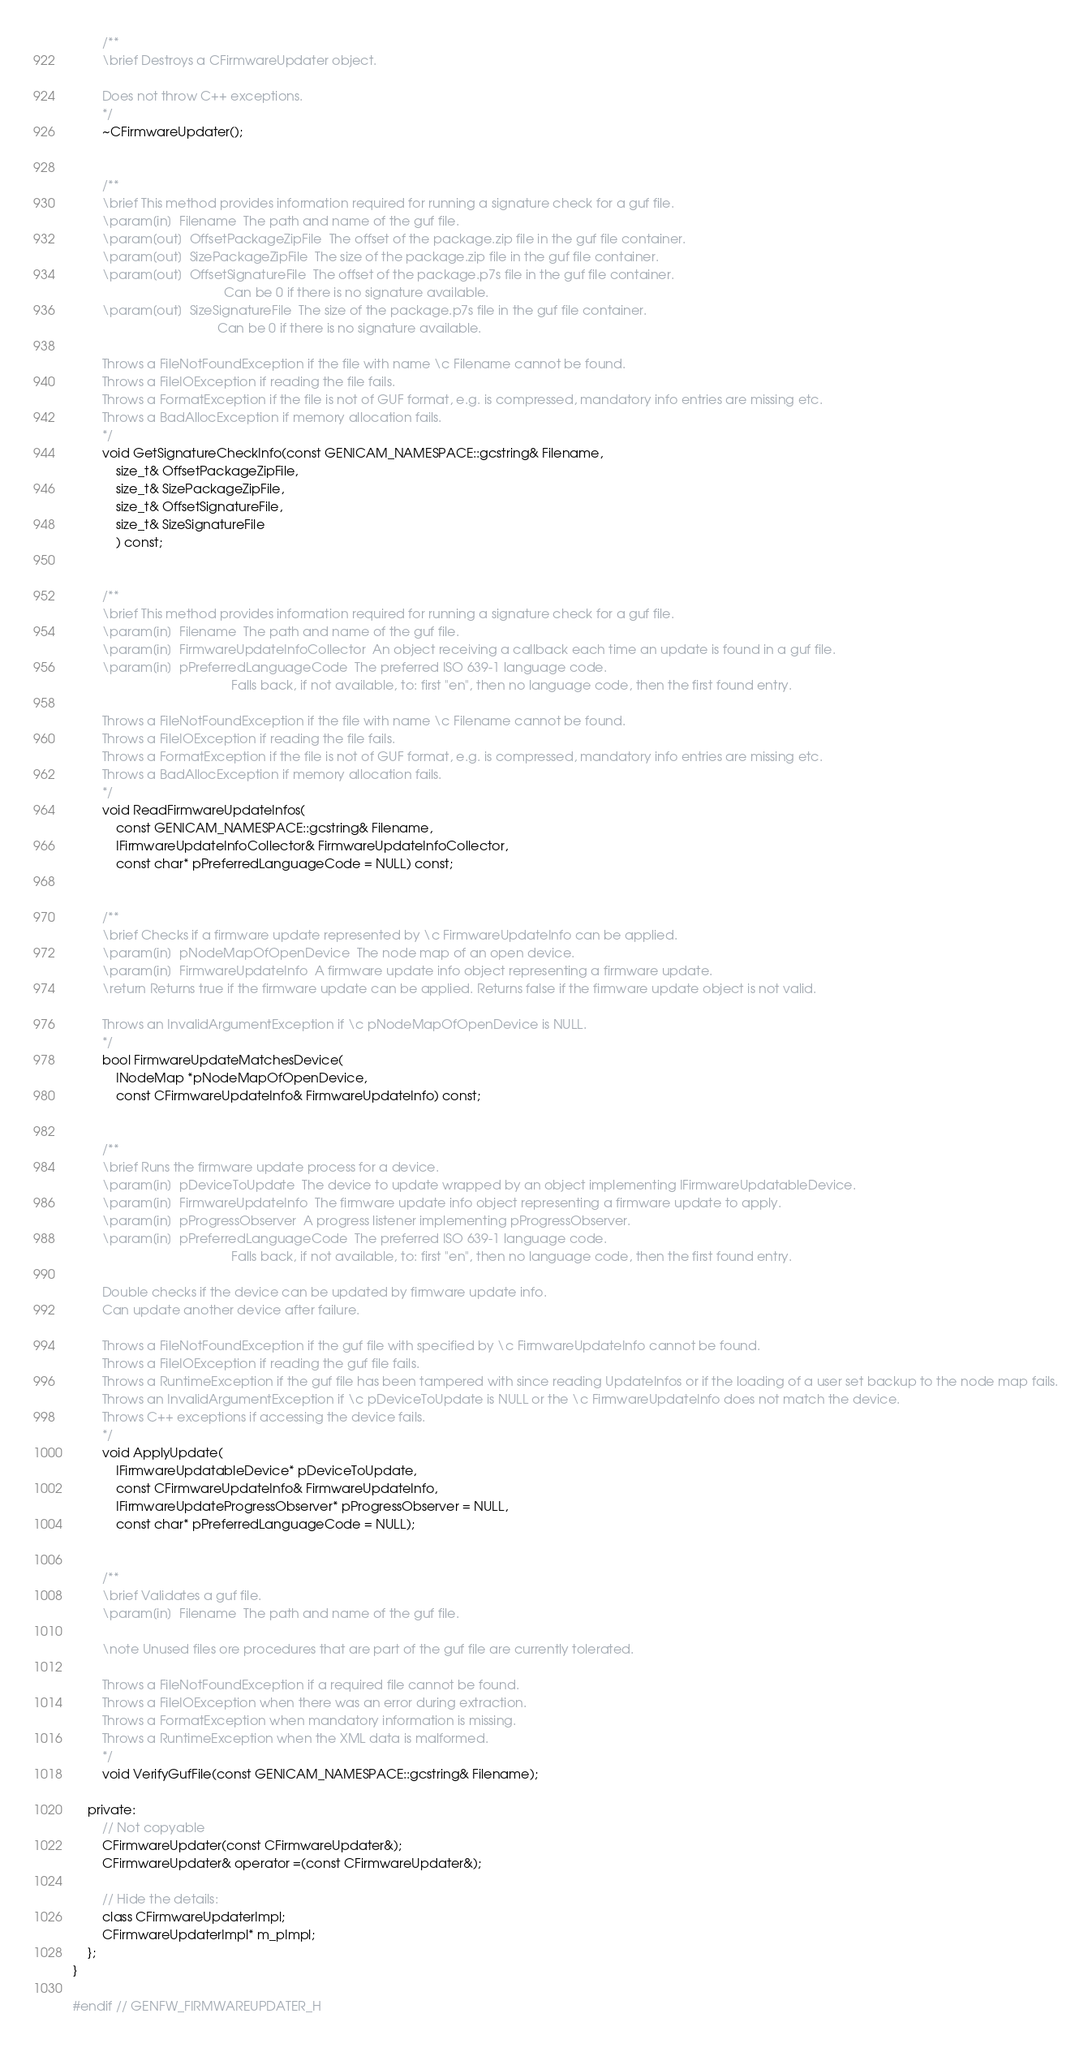<code> <loc_0><loc_0><loc_500><loc_500><_C_>
        /**
        \brief Destroys a CFirmwareUpdater object.

        Does not throw C++ exceptions.
        */
        ~CFirmwareUpdater();


        /**
        \brief This method provides information required for running a signature check for a guf file.
        \param[in]  Filename  The path and name of the guf file.
        \param[out]  OffsetPackageZipFile  The offset of the package.zip file in the guf file container.
        \param[out]  SizePackageZipFile  The size of the package.zip file in the guf file container.
        \param[out]  OffsetSignatureFile  The offset of the package.p7s file in the guf file container.
                                          Can be 0 if there is no signature available.
        \param[out]  SizeSignatureFile  The size of the package.p7s file in the guf file container.
                                        Can be 0 if there is no signature available.

        Throws a FileNotFoundException if the file with name \c Filename cannot be found.
        Throws a FileIOException if reading the file fails.
        Throws a FormatException if the file is not of GUF format, e.g. is compressed, mandatory info entries are missing etc. 
        Throws a BadAllocException if memory allocation fails.
        */
        void GetSignatureCheckInfo(const GENICAM_NAMESPACE::gcstring& Filename,
            size_t& OffsetPackageZipFile,
            size_t& SizePackageZipFile,
            size_t& OffsetSignatureFile,
            size_t& SizeSignatureFile
            ) const;


        /**
        \brief This method provides information required for running a signature check for a guf file.
        \param[in]  Filename  The path and name of the guf file.
        \param[in]  FirmwareUpdateInfoCollector  An object receiving a callback each time an update is found in a guf file.
        \param[in]  pPreferredLanguageCode  The preferred ISO 639-1 language code. 
                                            Falls back, if not available, to: first "en", then no language code, then the first found entry.

        Throws a FileNotFoundException if the file with name \c Filename cannot be found.
        Throws a FileIOException if reading the file fails.
        Throws a FormatException if the file is not of GUF format, e.g. is compressed, mandatory info entries are missing etc.
        Throws a BadAllocException if memory allocation fails.
        */
        void ReadFirmwareUpdateInfos(
            const GENICAM_NAMESPACE::gcstring& Filename,
            IFirmwareUpdateInfoCollector& FirmwareUpdateInfoCollector,
            const char* pPreferredLanguageCode = NULL) const;


        /**
        \brief Checks if a firmware update represented by \c FirmwareUpdateInfo can be applied.
        \param[in]  pNodeMapOfOpenDevice  The node map of an open device.
        \param[in]  FirmwareUpdateInfo  A firmware update info object representing a firmware update.
        \return Returns true if the firmware update can be applied. Returns false if the firmware update object is not valid.

        Throws an InvalidArgumentException if \c pNodeMapOfOpenDevice is NULL.
        */
        bool FirmwareUpdateMatchesDevice(
            INodeMap *pNodeMapOfOpenDevice,
            const CFirmwareUpdateInfo& FirmwareUpdateInfo) const;


        /**
        \brief Runs the firmware update process for a device.
        \param[in]  pDeviceToUpdate  The device to update wrapped by an object implementing IFirmwareUpdatableDevice.
        \param[in]  FirmwareUpdateInfo  The firmware update info object representing a firmware update to apply.
        \param[in]  pProgressObserver  A progress listener implementing pProgressObserver.
        \param[in]  pPreferredLanguageCode  The preferred ISO 639-1 language code.
                                            Falls back, if not available, to: first "en", then no language code, then the first found entry.

        Double checks if the device can be updated by firmware update info.
        Can update another device after failure.

        Throws a FileNotFoundException if the guf file with specified by \c FirmwareUpdateInfo cannot be found.
        Throws a FileIOException if reading the guf file fails.
        Throws a RuntimeException if the guf file has been tampered with since reading UpdateInfos or if the loading of a user set backup to the node map fails.
        Throws an InvalidArgumentException if \c pDeviceToUpdate is NULL or the \c FirmwareUpdateInfo does not match the device.
        Throws C++ exceptions if accessing the device fails.
        */
        void ApplyUpdate(
            IFirmwareUpdatableDevice* pDeviceToUpdate,
            const CFirmwareUpdateInfo& FirmwareUpdateInfo,
            IFirmwareUpdateProgressObserver* pProgressObserver = NULL,
            const char* pPreferredLanguageCode = NULL);


        /**
        \brief Validates a guf file.
        \param[in]  Filename  The path and name of the guf file.
        
        \note Unused files ore procedures that are part of the guf file are currently tolerated.

        Throws a FileNotFoundException if a required file cannot be found.
        Throws a FileIOException when there was an error during extraction.
        Throws a FormatException when mandatory information is missing.
        Throws a RuntimeException when the XML data is malformed.
        */
        void VerifyGufFile(const GENICAM_NAMESPACE::gcstring& Filename);

    private:
        // Not copyable
        CFirmwareUpdater(const CFirmwareUpdater&);
        CFirmwareUpdater& operator =(const CFirmwareUpdater&);

        // Hide the details:
        class CFirmwareUpdaterImpl;
        CFirmwareUpdaterImpl* m_pImpl;
    };
}

#endif // GENFW_FIRMWAREUPDATER_H
</code> 